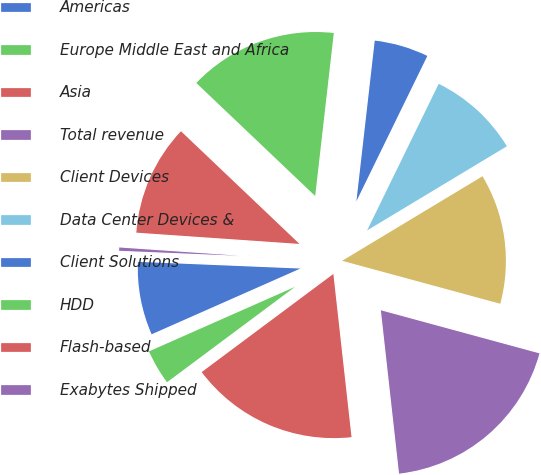Convert chart to OTSL. <chart><loc_0><loc_0><loc_500><loc_500><pie_chart><fcel>Americas<fcel>Europe Middle East and Africa<fcel>Asia<fcel>Total revenue<fcel>Client Devices<fcel>Data Center Devices &<fcel>Client Solutions<fcel>HDD<fcel>Flash-based<fcel>Exabytes Shipped<nl><fcel>7.28%<fcel>3.57%<fcel>16.57%<fcel>19.01%<fcel>12.85%<fcel>9.14%<fcel>5.42%<fcel>14.71%<fcel>11.0%<fcel>0.44%<nl></chart> 